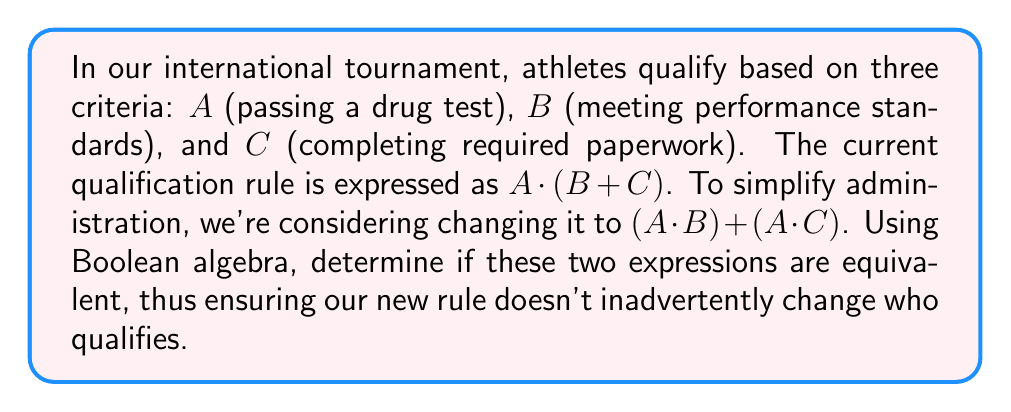Give your solution to this math problem. To determine if the expressions are equivalent, we'll use Boolean algebra laws:

1) Start with the original expression: $A \cdot (B + C)$

2) Apply the distributive law to expand this expression:
   $A \cdot (B + C) = (A \cdot B) + (A \cdot C)$

3) The right side of this equation is exactly the proposed new rule.

4) Since we've shown that $A \cdot (B + C) = (A \cdot B) + (A \cdot C)$ using Boolean algebra, we can conclude that these expressions are equivalent.

5) This means that the proposed new rule $(A \cdot B) + (A \cdot C)$ is logically identical to the current rule $A \cdot (B + C)$.

Therefore, changing the qualification rule from $A \cdot (B + C)$ to $(A \cdot B) + (A \cdot C)$ will not affect which athletes qualify for the tournament.
Answer: The expressions are equivalent. 